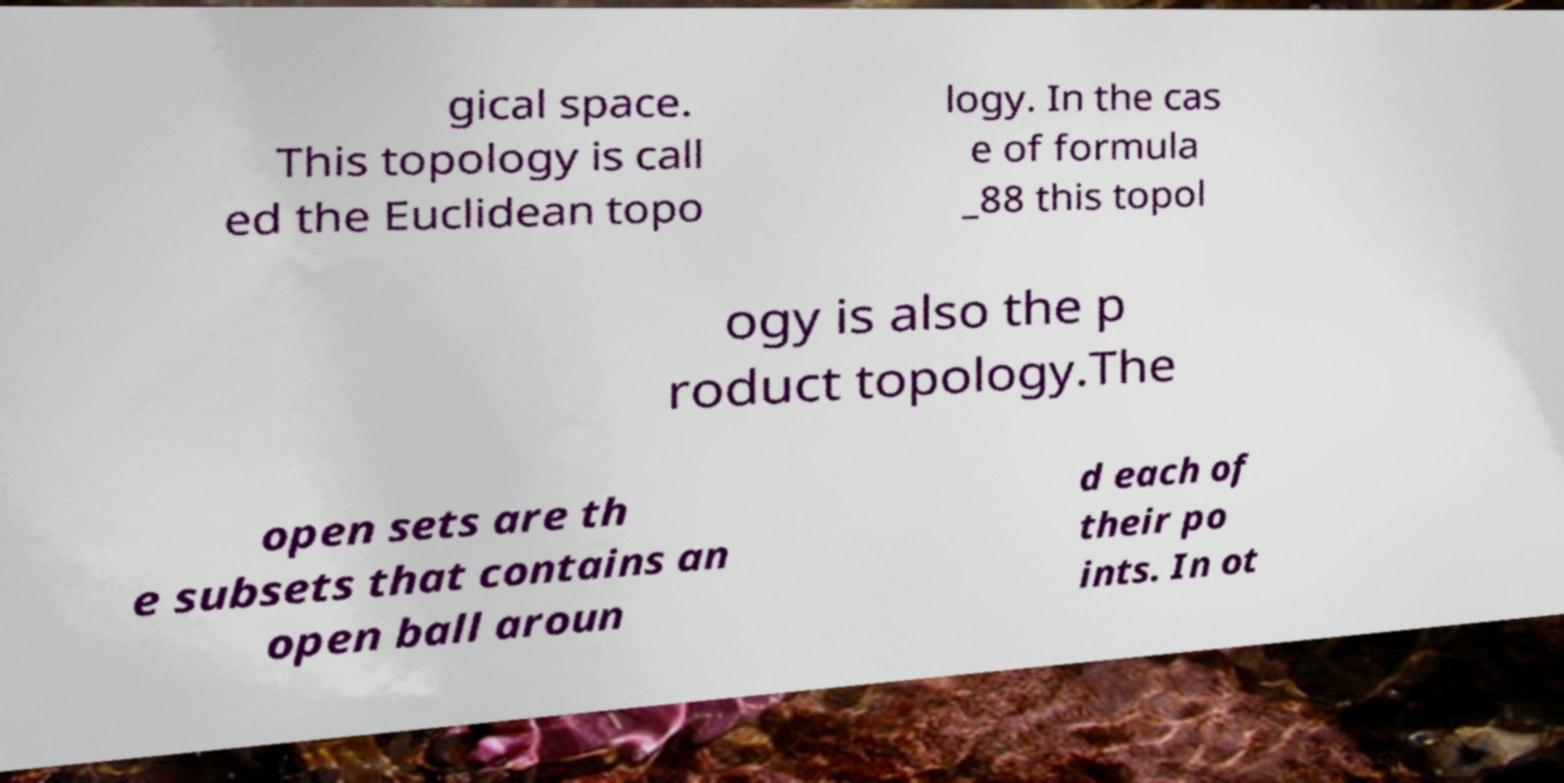Could you assist in decoding the text presented in this image and type it out clearly? gical space. This topology is call ed the Euclidean topo logy. In the cas e of formula _88 this topol ogy is also the p roduct topology.The open sets are th e subsets that contains an open ball aroun d each of their po ints. In ot 